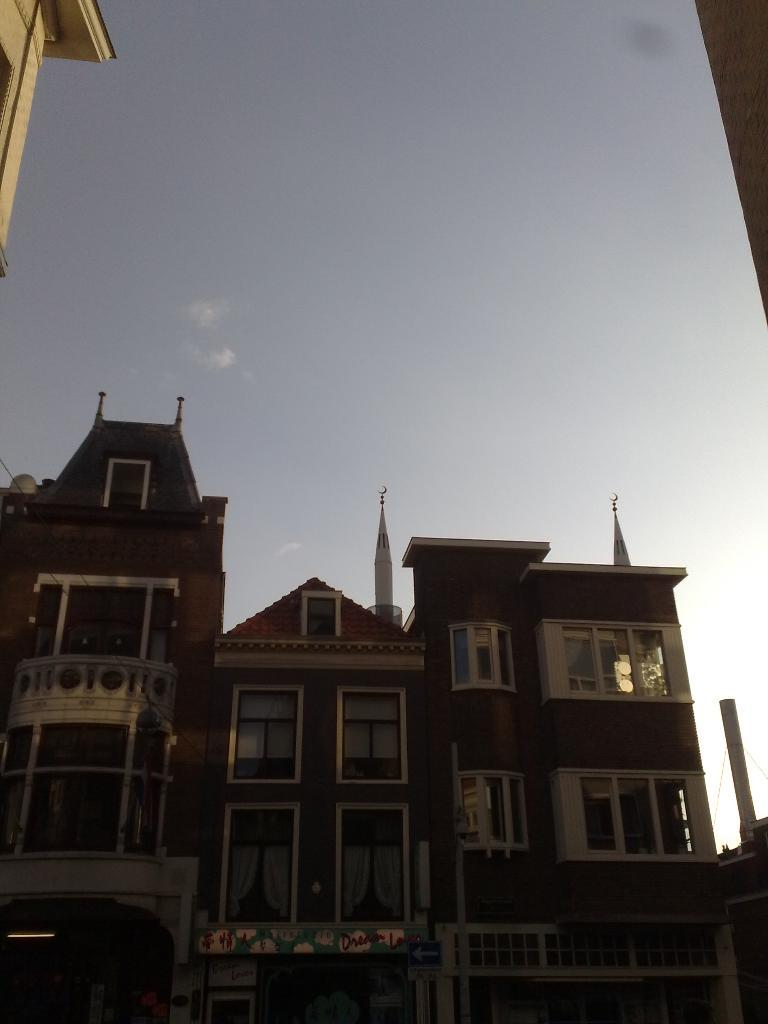What type of structure is present in the image? There is a building in the image. What are some features of the building? The building has windows and doors. What is the color of the building? The building is brown in color. What can be seen at the top of the image? The sky is visible at the top of the image. Where is the cup placed in the image? There is no cup present in the image. What type of roof is visible on the building in the image? The image does not show the roof of the building, so it cannot be determined from the image. 